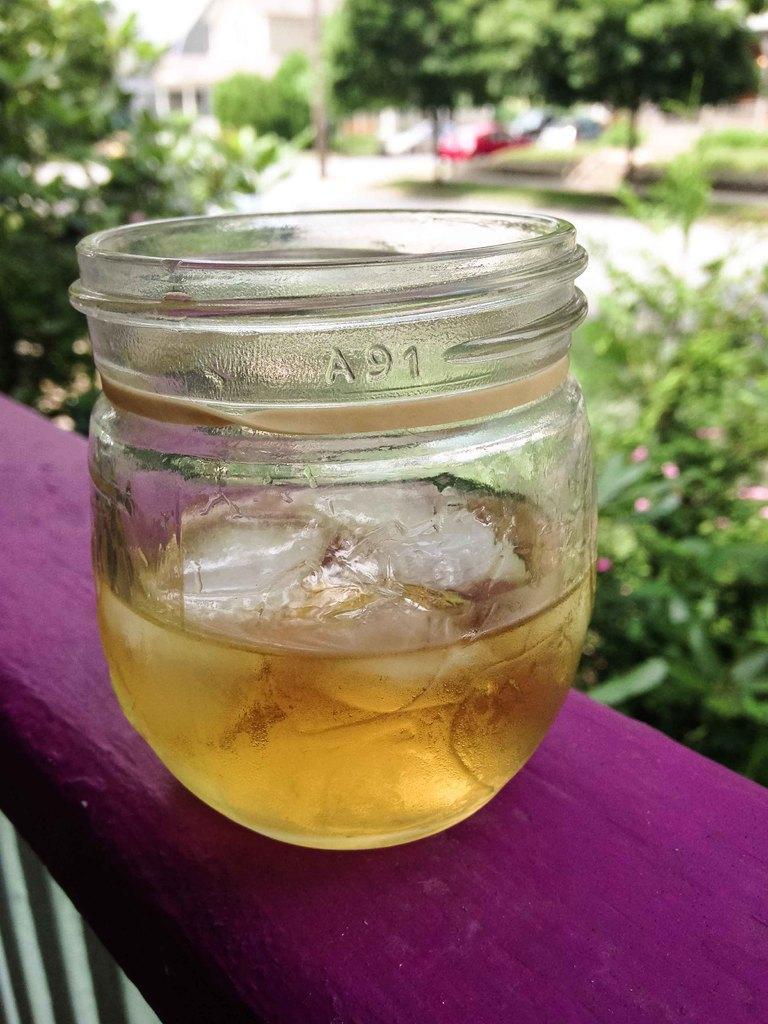Please provide a concise description of this image. In this picture I can see the violet color thing, on which I can see a jar and in the jar I can see the liquid and few white color things and I see an alphabet and 2 numbers written on the jar. In the background I can see number of trees and I see that it is blurred. 